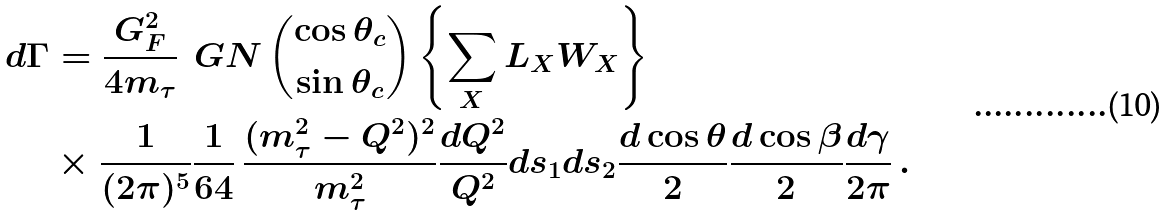Convert formula to latex. <formula><loc_0><loc_0><loc_500><loc_500>d \Gamma & = \frac { G _ { F } ^ { 2 } } { 4 m _ { \tau } } \, \ G N \, \binom { \cos \theta _ { c } } { \sin \theta _ { c } } \left \{ \sum _ { X } L _ { X } W _ { X } \right \} \\ & \times \frac { 1 } { ( 2 \pi ) ^ { 5 } } \frac { 1 } { 6 4 } \, \frac { ( m _ { \tau } ^ { 2 } - Q ^ { 2 } ) ^ { 2 } } { m _ { \tau } ^ { 2 } } \frac { d Q ^ { 2 } } { Q ^ { 2 } } d s _ { 1 } d s _ { 2 } \frac { d \cos \theta } { 2 } \frac { d \cos \beta } { 2 } \frac { d \gamma } { 2 \pi } \, .</formula> 